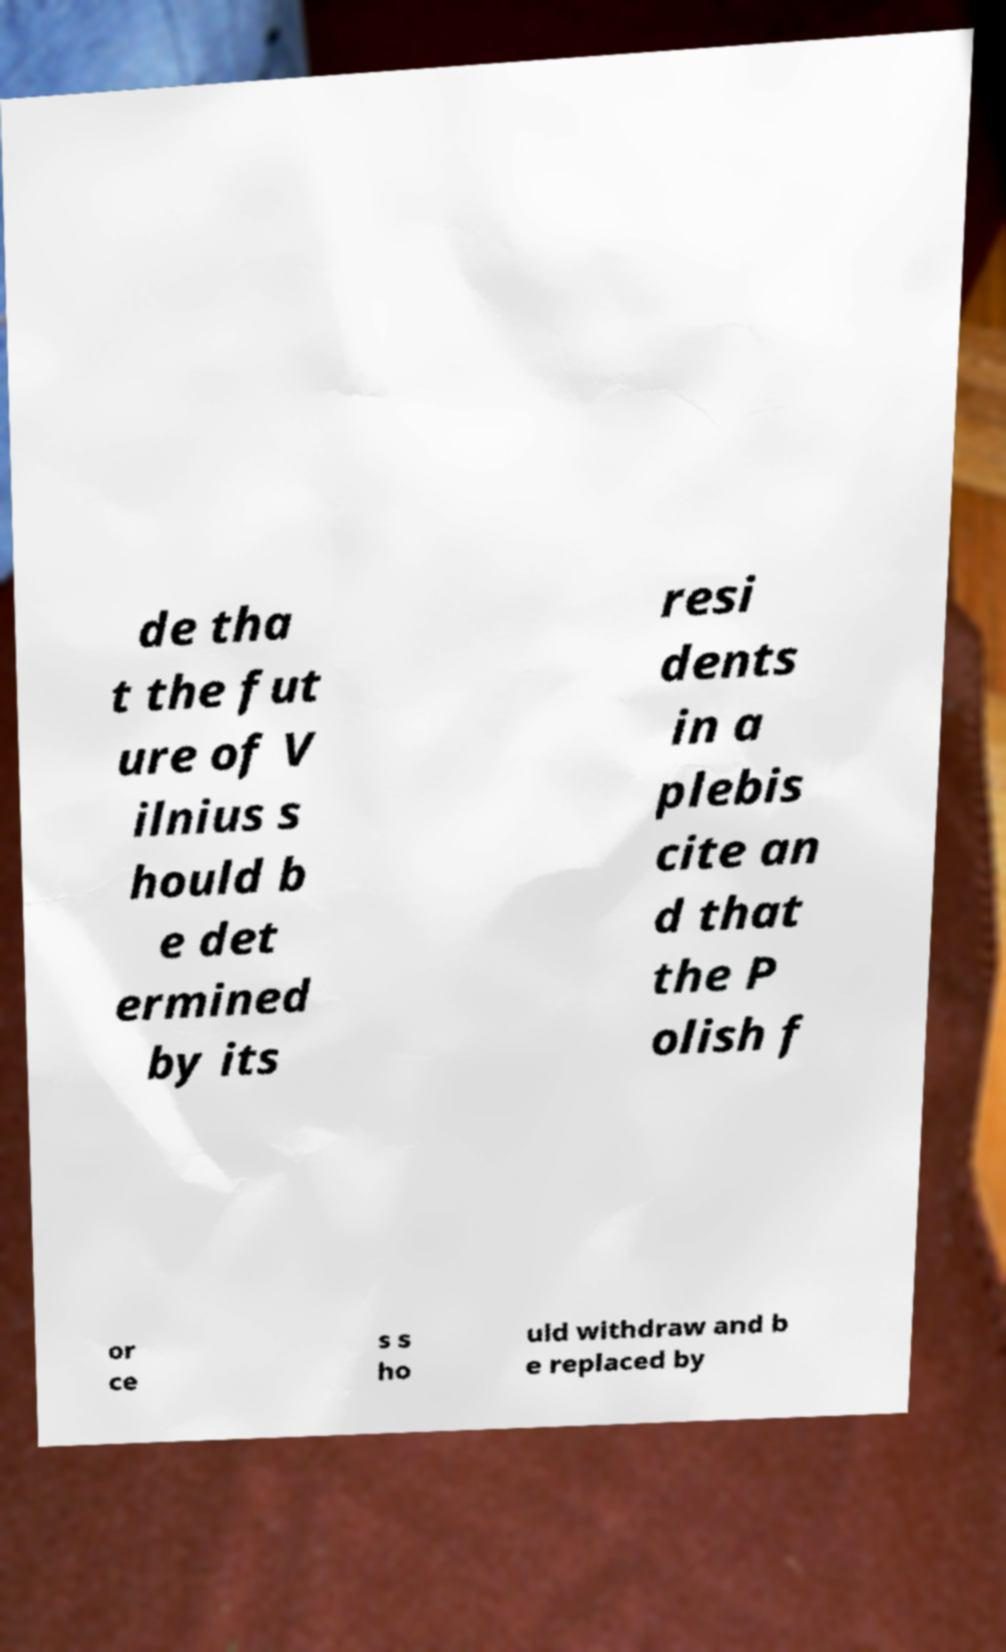For documentation purposes, I need the text within this image transcribed. Could you provide that? de tha t the fut ure of V ilnius s hould b e det ermined by its resi dents in a plebis cite an d that the P olish f or ce s s ho uld withdraw and b e replaced by 